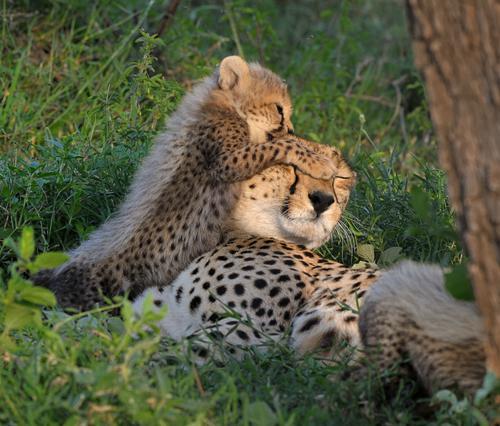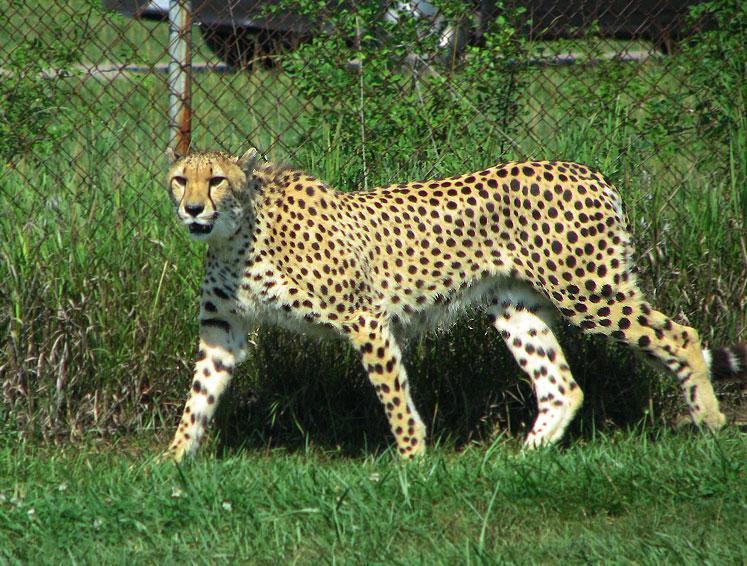The first image is the image on the left, the second image is the image on the right. Analyze the images presented: Is the assertion "There are at least five cheetah in the pair of images." valid? Answer yes or no. No. The first image is the image on the left, the second image is the image on the right. Considering the images on both sides, is "The left image contains at least four cheetahs." valid? Answer yes or no. No. 